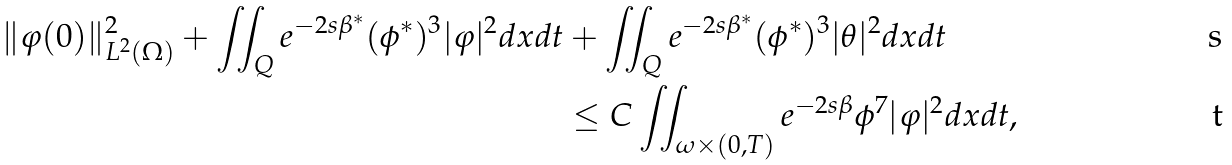Convert formula to latex. <formula><loc_0><loc_0><loc_500><loc_500>\| \varphi ( 0 ) \| ^ { 2 } _ { L ^ { 2 } ( \Omega ) } + \iint _ { Q } e ^ { - 2 s \beta ^ { * } } ( \phi ^ { * } ) ^ { 3 } | \varphi | ^ { 2 } d x d t & + \iint _ { Q } e ^ { - 2 s \beta ^ { * } } ( \phi ^ { * } ) ^ { 3 } | \theta | ^ { 2 } d x d t \\ & \leq C \iint _ { \omega \times ( 0 , T ) } e ^ { - 2 s \beta } \phi ^ { 7 } | \varphi | ^ { 2 } d x d t ,</formula> 